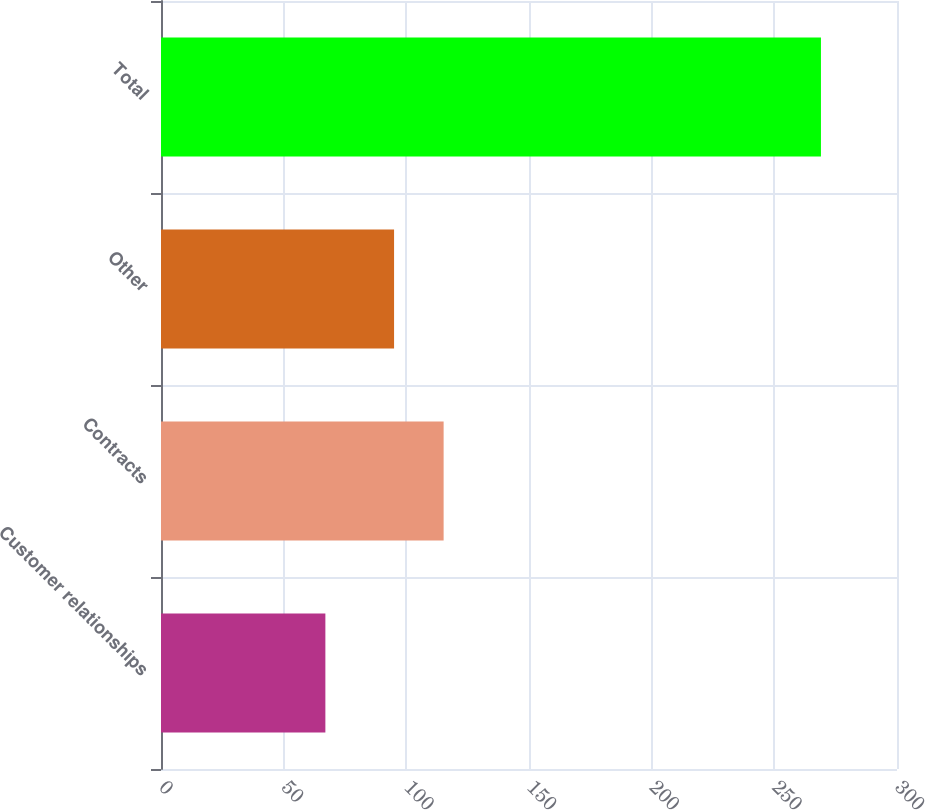Convert chart. <chart><loc_0><loc_0><loc_500><loc_500><bar_chart><fcel>Customer relationships<fcel>Contracts<fcel>Other<fcel>Total<nl><fcel>67<fcel>115.2<fcel>95<fcel>269<nl></chart> 